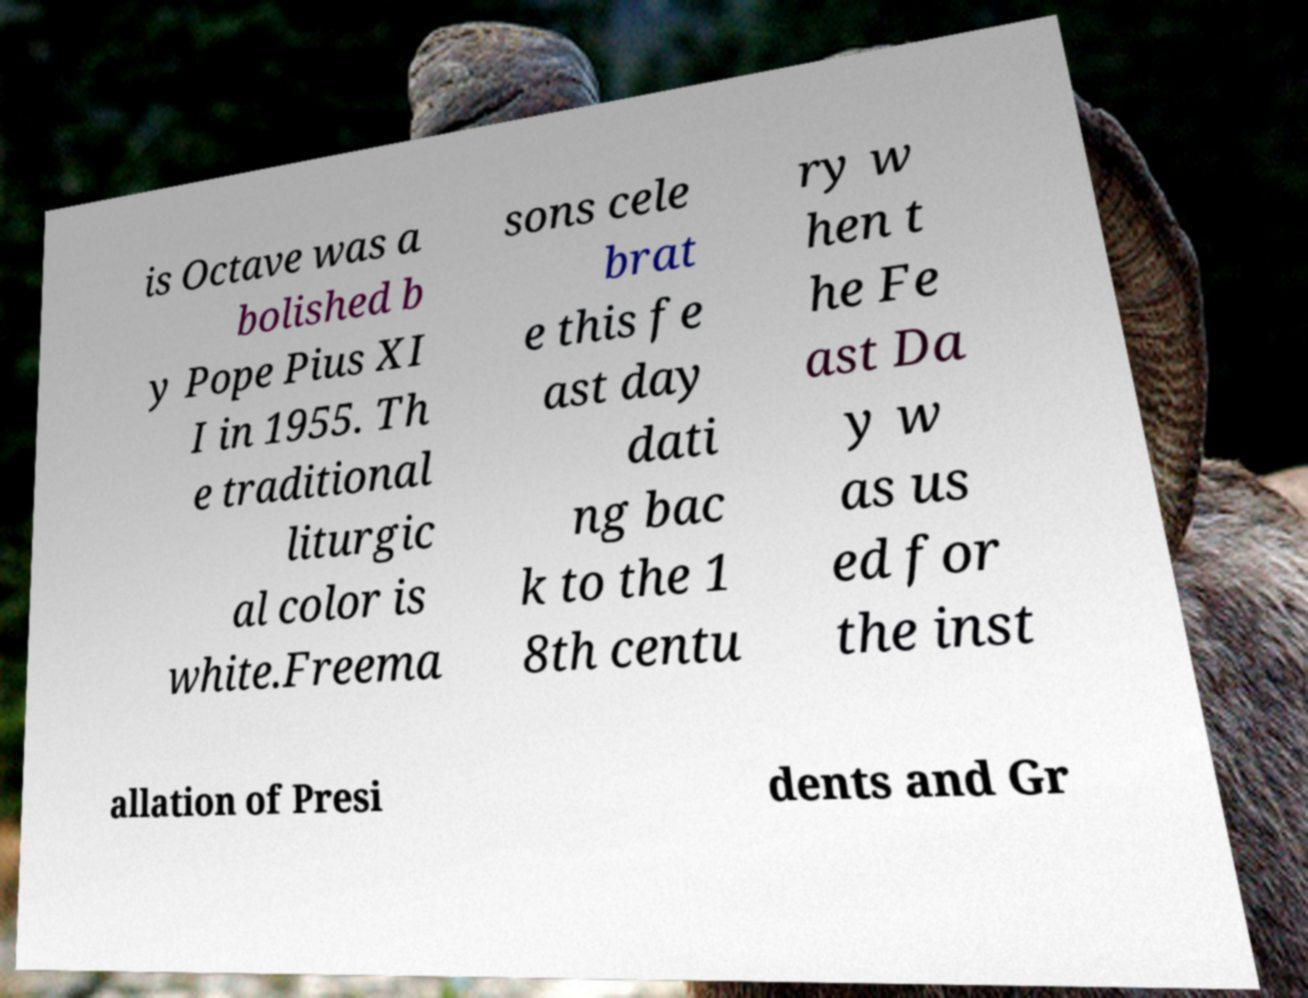Can you accurately transcribe the text from the provided image for me? is Octave was a bolished b y Pope Pius XI I in 1955. Th e traditional liturgic al color is white.Freema sons cele brat e this fe ast day dati ng bac k to the 1 8th centu ry w hen t he Fe ast Da y w as us ed for the inst allation of Presi dents and Gr 